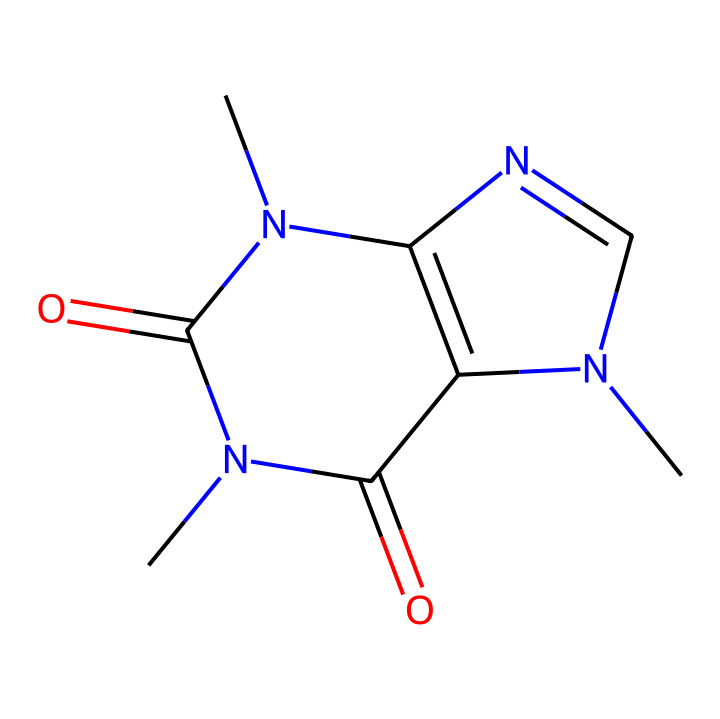What is the primary atom present in caffeine? The SMILES structure contains a lot of carbon atoms (C), but it also features elements such as nitrogen (N) and oxygen (O). However, since the question asks for the primary atom contributing to the structure, we identify carbon due to its abundance and central role in organic molecules.
Answer: carbon How many nitrogen atoms are in the caffeine structure? In the provided SMILES representation, we can count the nitrogen atoms denoted by 'N'. There are a total of three 'N' symbols present in the chemical structure.
Answer: three What type of chemical is caffeine? Caffeine is classified as a purine alkaloid based on its structure, which includes nitrogenous bases and is derived from plants. The presence of multiple nitrogen atoms characterizes it as an alkaloid.
Answer: alkaloid What is the total number of rings present in the caffeine structure? To determine the number of rings, we look for cycles in the structure represented by the bonds. The SMILES shows that caffeine has a bicyclic structure. Thus, there are two interconnected rings present in its chemical structure.
Answer: two Does this chemical structure contain double bonds? By analyzing the SMILES format, we can see that there are instances where a double bond is specified, indicated by the "=" symbol. This confirms that there are indeed double bonds in the structure, particularly in the carbonyl groups.
Answer: yes 